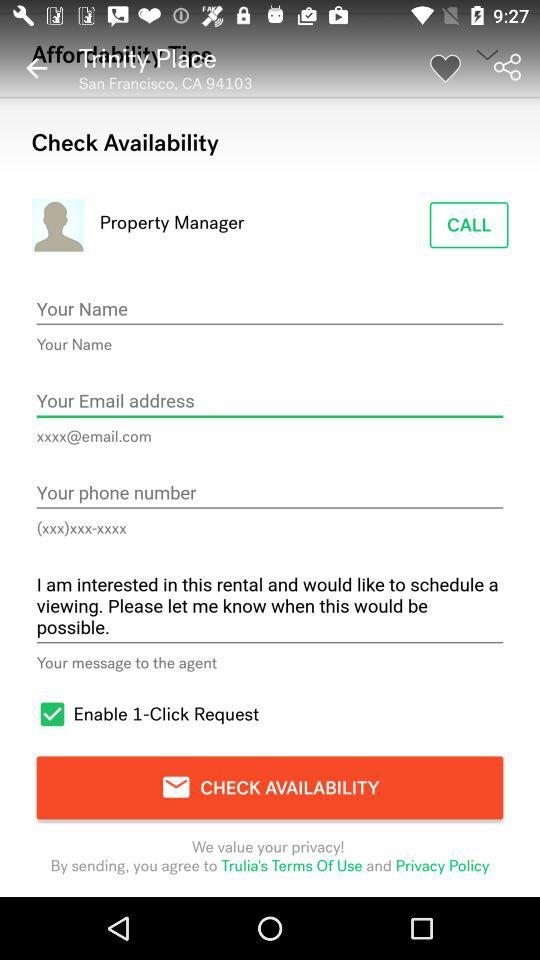What is the status of the "Enable 1-Click Request"? The status is "on". 